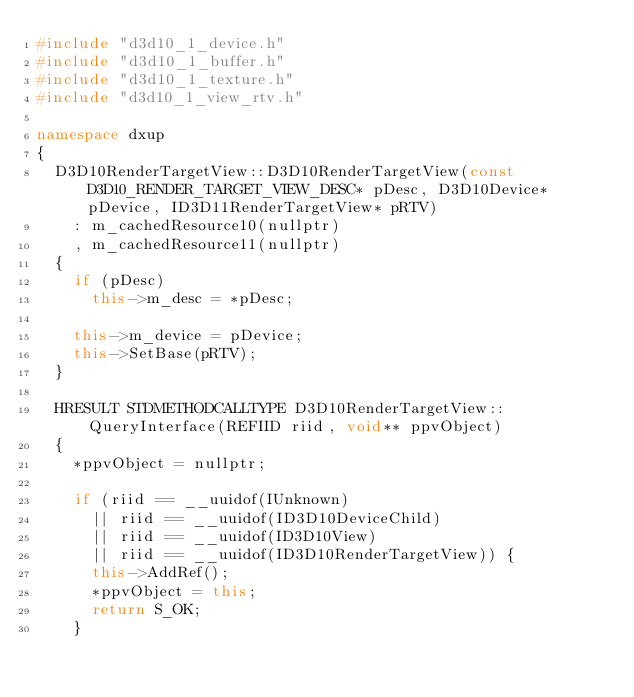Convert code to text. <code><loc_0><loc_0><loc_500><loc_500><_C++_>#include "d3d10_1_device.h"
#include "d3d10_1_buffer.h"
#include "d3d10_1_texture.h"
#include "d3d10_1_view_rtv.h"

namespace dxup
{
	D3D10RenderTargetView::D3D10RenderTargetView(const D3D10_RENDER_TARGET_VIEW_DESC* pDesc, D3D10Device* pDevice, ID3D11RenderTargetView* pRTV)
		: m_cachedResource10(nullptr)
		, m_cachedResource11(nullptr)
	{
		if (pDesc)
			this->m_desc = *pDesc;

		this->m_device = pDevice;
		this->SetBase(pRTV);
	}

	HRESULT STDMETHODCALLTYPE D3D10RenderTargetView::QueryInterface(REFIID riid, void** ppvObject)
	{
		*ppvObject = nullptr;

		if (riid == __uuidof(IUnknown)
			|| riid == __uuidof(ID3D10DeviceChild)
			|| riid == __uuidof(ID3D10View)
			|| riid == __uuidof(ID3D10RenderTargetView)) {
			this->AddRef();
			*ppvObject = this;
			return S_OK;
		}
</code> 